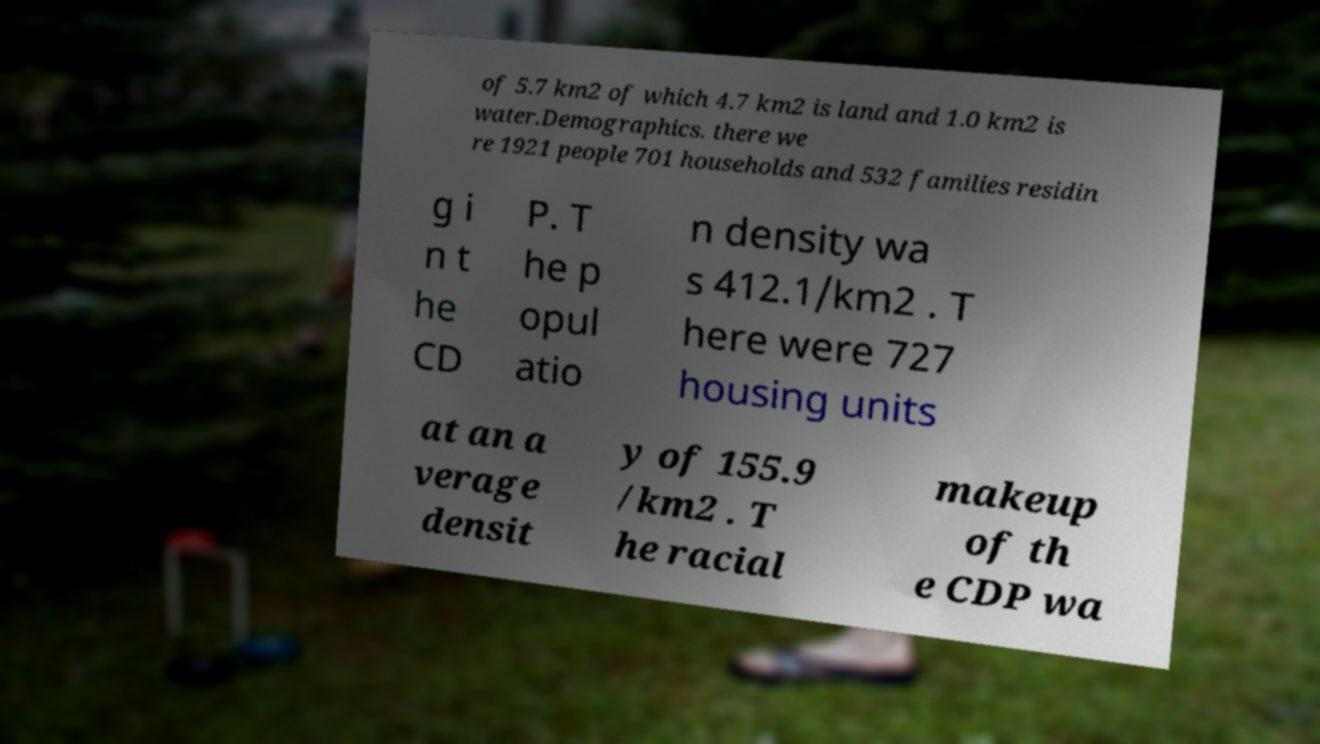Please read and relay the text visible in this image. What does it say? of 5.7 km2 of which 4.7 km2 is land and 1.0 km2 is water.Demographics. there we re 1921 people 701 households and 532 families residin g i n t he CD P. T he p opul atio n density wa s 412.1/km2 . T here were 727 housing units at an a verage densit y of 155.9 /km2 . T he racial makeup of th e CDP wa 